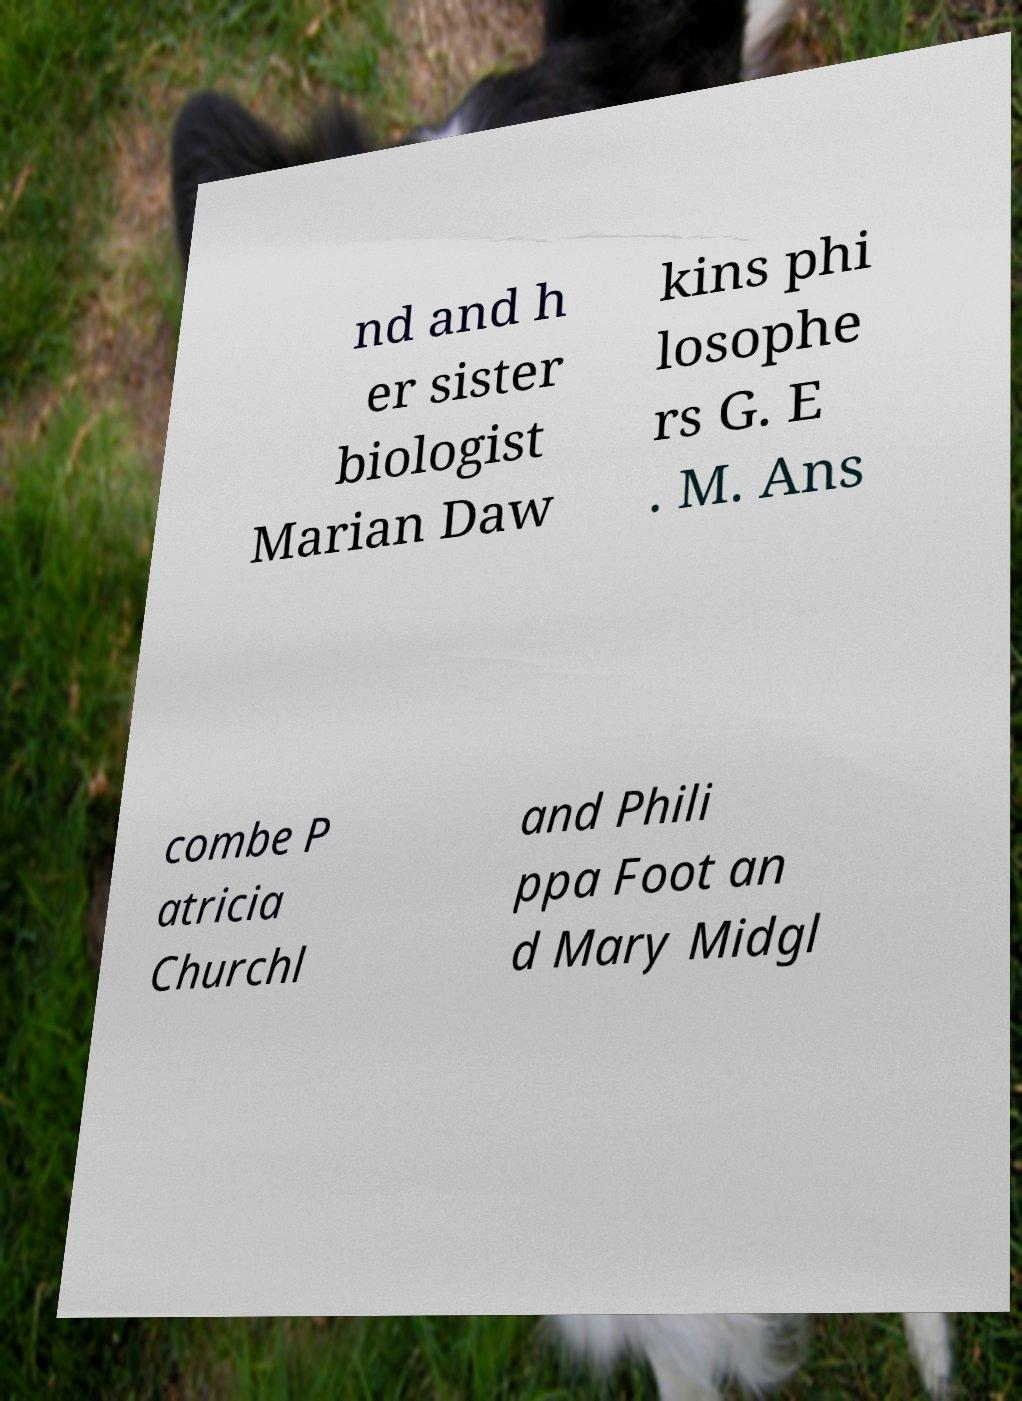I need the written content from this picture converted into text. Can you do that? nd and h er sister biologist Marian Daw kins phi losophe rs G. E . M. Ans combe P atricia Churchl and Phili ppa Foot an d Mary Midgl 